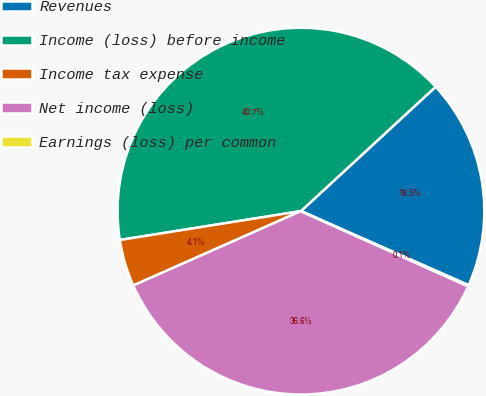Convert chart. <chart><loc_0><loc_0><loc_500><loc_500><pie_chart><fcel>Revenues<fcel>Income (loss) before income<fcel>Income tax expense<fcel>Net income (loss)<fcel>Earnings (loss) per common<nl><fcel>18.48%<fcel>40.65%<fcel>4.13%<fcel>36.62%<fcel>0.11%<nl></chart> 